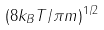<formula> <loc_0><loc_0><loc_500><loc_500>( 8 k _ { B } T / \pi m ) ^ { 1 / 2 }</formula> 